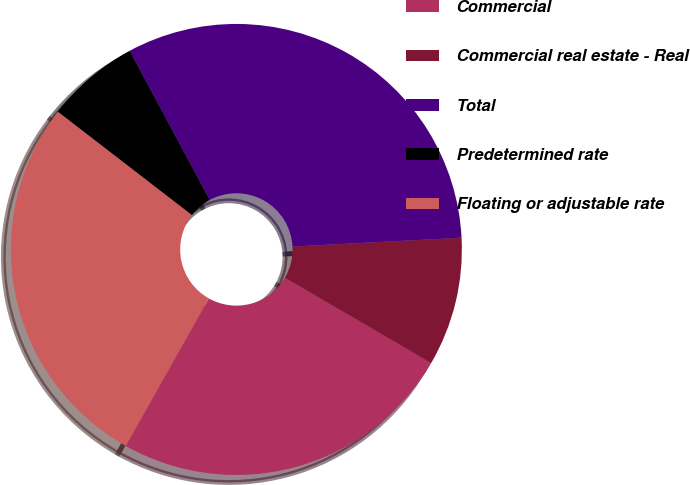Convert chart. <chart><loc_0><loc_0><loc_500><loc_500><pie_chart><fcel>Commercial<fcel>Commercial real estate - Real<fcel>Total<fcel>Predetermined rate<fcel>Floating or adjustable rate<nl><fcel>24.76%<fcel>9.23%<fcel>32.02%<fcel>6.7%<fcel>27.29%<nl></chart> 